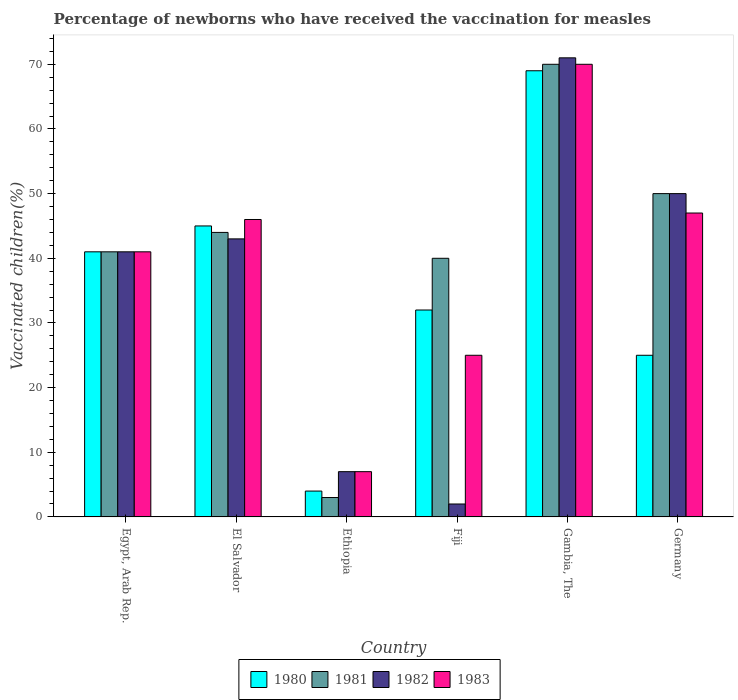How many different coloured bars are there?
Your answer should be very brief. 4. How many groups of bars are there?
Offer a terse response. 6. Are the number of bars per tick equal to the number of legend labels?
Ensure brevity in your answer.  Yes. Are the number of bars on each tick of the X-axis equal?
Provide a short and direct response. Yes. How many bars are there on the 2nd tick from the left?
Give a very brief answer. 4. How many bars are there on the 5th tick from the right?
Provide a succinct answer. 4. What is the label of the 1st group of bars from the left?
Offer a terse response. Egypt, Arab Rep. In which country was the percentage of vaccinated children in 1981 maximum?
Make the answer very short. Gambia, The. In which country was the percentage of vaccinated children in 1980 minimum?
Make the answer very short. Ethiopia. What is the total percentage of vaccinated children in 1982 in the graph?
Provide a short and direct response. 214. What is the difference between the percentage of vaccinated children in 1981 in Egypt, Arab Rep. and that in Germany?
Offer a terse response. -9. What is the average percentage of vaccinated children in 1983 per country?
Your answer should be very brief. 39.33. In how many countries, is the percentage of vaccinated children in 1981 greater than 42 %?
Keep it short and to the point. 3. What is the ratio of the percentage of vaccinated children in 1980 in Egypt, Arab Rep. to that in Fiji?
Provide a short and direct response. 1.28. Is the percentage of vaccinated children in 1981 in Ethiopia less than that in Germany?
Give a very brief answer. Yes. In how many countries, is the percentage of vaccinated children in 1981 greater than the average percentage of vaccinated children in 1981 taken over all countries?
Ensure brevity in your answer.  3. What does the 1st bar from the left in Fiji represents?
Offer a very short reply. 1980. Is it the case that in every country, the sum of the percentage of vaccinated children in 1982 and percentage of vaccinated children in 1981 is greater than the percentage of vaccinated children in 1983?
Provide a short and direct response. Yes. How many bars are there?
Make the answer very short. 24. What is the difference between two consecutive major ticks on the Y-axis?
Keep it short and to the point. 10. Does the graph contain grids?
Your answer should be compact. No. Where does the legend appear in the graph?
Keep it short and to the point. Bottom center. What is the title of the graph?
Provide a succinct answer. Percentage of newborns who have received the vaccination for measles. What is the label or title of the Y-axis?
Offer a terse response. Vaccinated children(%). What is the Vaccinated children(%) of 1982 in Egypt, Arab Rep.?
Make the answer very short. 41. What is the Vaccinated children(%) in 1980 in El Salvador?
Offer a terse response. 45. What is the Vaccinated children(%) of 1983 in El Salvador?
Offer a terse response. 46. What is the Vaccinated children(%) of 1980 in Ethiopia?
Give a very brief answer. 4. What is the Vaccinated children(%) of 1982 in Ethiopia?
Your response must be concise. 7. What is the Vaccinated children(%) of 1983 in Ethiopia?
Offer a very short reply. 7. What is the Vaccinated children(%) of 1981 in Fiji?
Provide a short and direct response. 40. What is the Vaccinated children(%) of 1982 in Fiji?
Ensure brevity in your answer.  2. What is the Vaccinated children(%) in 1982 in Gambia, The?
Keep it short and to the point. 71. What is the Vaccinated children(%) in 1980 in Germany?
Ensure brevity in your answer.  25. Across all countries, what is the maximum Vaccinated children(%) of 1982?
Offer a very short reply. 71. Across all countries, what is the minimum Vaccinated children(%) in 1980?
Keep it short and to the point. 4. Across all countries, what is the minimum Vaccinated children(%) in 1982?
Your answer should be very brief. 2. What is the total Vaccinated children(%) of 1980 in the graph?
Your response must be concise. 216. What is the total Vaccinated children(%) in 1981 in the graph?
Your answer should be compact. 248. What is the total Vaccinated children(%) in 1982 in the graph?
Your answer should be very brief. 214. What is the total Vaccinated children(%) of 1983 in the graph?
Provide a short and direct response. 236. What is the difference between the Vaccinated children(%) of 1981 in Egypt, Arab Rep. and that in El Salvador?
Offer a very short reply. -3. What is the difference between the Vaccinated children(%) of 1982 in Egypt, Arab Rep. and that in El Salvador?
Provide a succinct answer. -2. What is the difference between the Vaccinated children(%) in 1981 in Egypt, Arab Rep. and that in Ethiopia?
Your answer should be very brief. 38. What is the difference between the Vaccinated children(%) in 1983 in Egypt, Arab Rep. and that in Ethiopia?
Keep it short and to the point. 34. What is the difference between the Vaccinated children(%) in 1981 in Egypt, Arab Rep. and that in Fiji?
Offer a very short reply. 1. What is the difference between the Vaccinated children(%) in 1982 in Egypt, Arab Rep. and that in Fiji?
Your answer should be very brief. 39. What is the difference between the Vaccinated children(%) of 1980 in Egypt, Arab Rep. and that in Germany?
Offer a terse response. 16. What is the difference between the Vaccinated children(%) of 1982 in Egypt, Arab Rep. and that in Germany?
Offer a terse response. -9. What is the difference between the Vaccinated children(%) in 1980 in El Salvador and that in Ethiopia?
Ensure brevity in your answer.  41. What is the difference between the Vaccinated children(%) in 1982 in El Salvador and that in Ethiopia?
Your answer should be very brief. 36. What is the difference between the Vaccinated children(%) in 1981 in El Salvador and that in Fiji?
Your answer should be very brief. 4. What is the difference between the Vaccinated children(%) in 1980 in El Salvador and that in Gambia, The?
Offer a very short reply. -24. What is the difference between the Vaccinated children(%) of 1983 in El Salvador and that in Gambia, The?
Provide a short and direct response. -24. What is the difference between the Vaccinated children(%) in 1982 in El Salvador and that in Germany?
Provide a short and direct response. -7. What is the difference between the Vaccinated children(%) in 1983 in El Salvador and that in Germany?
Ensure brevity in your answer.  -1. What is the difference between the Vaccinated children(%) in 1980 in Ethiopia and that in Fiji?
Give a very brief answer. -28. What is the difference between the Vaccinated children(%) in 1981 in Ethiopia and that in Fiji?
Your answer should be very brief. -37. What is the difference between the Vaccinated children(%) of 1980 in Ethiopia and that in Gambia, The?
Offer a terse response. -65. What is the difference between the Vaccinated children(%) of 1981 in Ethiopia and that in Gambia, The?
Your answer should be compact. -67. What is the difference between the Vaccinated children(%) of 1982 in Ethiopia and that in Gambia, The?
Make the answer very short. -64. What is the difference between the Vaccinated children(%) in 1983 in Ethiopia and that in Gambia, The?
Make the answer very short. -63. What is the difference between the Vaccinated children(%) of 1981 in Ethiopia and that in Germany?
Provide a succinct answer. -47. What is the difference between the Vaccinated children(%) of 1982 in Ethiopia and that in Germany?
Your answer should be compact. -43. What is the difference between the Vaccinated children(%) of 1980 in Fiji and that in Gambia, The?
Provide a short and direct response. -37. What is the difference between the Vaccinated children(%) of 1982 in Fiji and that in Gambia, The?
Your response must be concise. -69. What is the difference between the Vaccinated children(%) in 1983 in Fiji and that in Gambia, The?
Ensure brevity in your answer.  -45. What is the difference between the Vaccinated children(%) of 1981 in Fiji and that in Germany?
Your answer should be compact. -10. What is the difference between the Vaccinated children(%) in 1982 in Fiji and that in Germany?
Keep it short and to the point. -48. What is the difference between the Vaccinated children(%) in 1980 in Gambia, The and that in Germany?
Keep it short and to the point. 44. What is the difference between the Vaccinated children(%) of 1981 in Gambia, The and that in Germany?
Give a very brief answer. 20. What is the difference between the Vaccinated children(%) of 1982 in Gambia, The and that in Germany?
Your answer should be very brief. 21. What is the difference between the Vaccinated children(%) of 1983 in Gambia, The and that in Germany?
Your answer should be compact. 23. What is the difference between the Vaccinated children(%) of 1980 in Egypt, Arab Rep. and the Vaccinated children(%) of 1982 in El Salvador?
Keep it short and to the point. -2. What is the difference between the Vaccinated children(%) in 1980 in Egypt, Arab Rep. and the Vaccinated children(%) in 1983 in El Salvador?
Your answer should be very brief. -5. What is the difference between the Vaccinated children(%) in 1981 in Egypt, Arab Rep. and the Vaccinated children(%) in 1982 in El Salvador?
Provide a short and direct response. -2. What is the difference between the Vaccinated children(%) of 1982 in Egypt, Arab Rep. and the Vaccinated children(%) of 1983 in El Salvador?
Provide a succinct answer. -5. What is the difference between the Vaccinated children(%) in 1980 in Egypt, Arab Rep. and the Vaccinated children(%) in 1981 in Ethiopia?
Offer a very short reply. 38. What is the difference between the Vaccinated children(%) of 1982 in Egypt, Arab Rep. and the Vaccinated children(%) of 1983 in Ethiopia?
Your answer should be compact. 34. What is the difference between the Vaccinated children(%) of 1980 in Egypt, Arab Rep. and the Vaccinated children(%) of 1982 in Fiji?
Give a very brief answer. 39. What is the difference between the Vaccinated children(%) of 1980 in Egypt, Arab Rep. and the Vaccinated children(%) of 1983 in Fiji?
Make the answer very short. 16. What is the difference between the Vaccinated children(%) of 1980 in Egypt, Arab Rep. and the Vaccinated children(%) of 1983 in Gambia, The?
Provide a succinct answer. -29. What is the difference between the Vaccinated children(%) in 1981 in Egypt, Arab Rep. and the Vaccinated children(%) in 1982 in Gambia, The?
Your answer should be compact. -30. What is the difference between the Vaccinated children(%) in 1980 in Egypt, Arab Rep. and the Vaccinated children(%) in 1981 in Germany?
Provide a short and direct response. -9. What is the difference between the Vaccinated children(%) in 1980 in Egypt, Arab Rep. and the Vaccinated children(%) in 1982 in Germany?
Make the answer very short. -9. What is the difference between the Vaccinated children(%) of 1980 in Egypt, Arab Rep. and the Vaccinated children(%) of 1983 in Germany?
Provide a short and direct response. -6. What is the difference between the Vaccinated children(%) of 1981 in Egypt, Arab Rep. and the Vaccinated children(%) of 1983 in Germany?
Ensure brevity in your answer.  -6. What is the difference between the Vaccinated children(%) of 1982 in Egypt, Arab Rep. and the Vaccinated children(%) of 1983 in Germany?
Give a very brief answer. -6. What is the difference between the Vaccinated children(%) in 1980 in El Salvador and the Vaccinated children(%) in 1982 in Ethiopia?
Give a very brief answer. 38. What is the difference between the Vaccinated children(%) in 1980 in El Salvador and the Vaccinated children(%) in 1983 in Ethiopia?
Your answer should be very brief. 38. What is the difference between the Vaccinated children(%) in 1982 in El Salvador and the Vaccinated children(%) in 1983 in Ethiopia?
Your answer should be compact. 36. What is the difference between the Vaccinated children(%) in 1980 in El Salvador and the Vaccinated children(%) in 1982 in Fiji?
Keep it short and to the point. 43. What is the difference between the Vaccinated children(%) in 1980 in El Salvador and the Vaccinated children(%) in 1983 in Fiji?
Provide a succinct answer. 20. What is the difference between the Vaccinated children(%) of 1981 in El Salvador and the Vaccinated children(%) of 1982 in Fiji?
Your answer should be compact. 42. What is the difference between the Vaccinated children(%) of 1981 in El Salvador and the Vaccinated children(%) of 1983 in Fiji?
Offer a terse response. 19. What is the difference between the Vaccinated children(%) of 1980 in El Salvador and the Vaccinated children(%) of 1981 in Gambia, The?
Your answer should be compact. -25. What is the difference between the Vaccinated children(%) in 1980 in El Salvador and the Vaccinated children(%) in 1982 in Gambia, The?
Your answer should be compact. -26. What is the difference between the Vaccinated children(%) of 1981 in El Salvador and the Vaccinated children(%) of 1983 in Gambia, The?
Ensure brevity in your answer.  -26. What is the difference between the Vaccinated children(%) in 1982 in El Salvador and the Vaccinated children(%) in 1983 in Gambia, The?
Your response must be concise. -27. What is the difference between the Vaccinated children(%) of 1980 in El Salvador and the Vaccinated children(%) of 1981 in Germany?
Make the answer very short. -5. What is the difference between the Vaccinated children(%) of 1980 in El Salvador and the Vaccinated children(%) of 1982 in Germany?
Give a very brief answer. -5. What is the difference between the Vaccinated children(%) of 1981 in El Salvador and the Vaccinated children(%) of 1983 in Germany?
Provide a succinct answer. -3. What is the difference between the Vaccinated children(%) of 1982 in El Salvador and the Vaccinated children(%) of 1983 in Germany?
Ensure brevity in your answer.  -4. What is the difference between the Vaccinated children(%) in 1980 in Ethiopia and the Vaccinated children(%) in 1981 in Fiji?
Your response must be concise. -36. What is the difference between the Vaccinated children(%) of 1980 in Ethiopia and the Vaccinated children(%) of 1983 in Fiji?
Give a very brief answer. -21. What is the difference between the Vaccinated children(%) in 1981 in Ethiopia and the Vaccinated children(%) in 1983 in Fiji?
Ensure brevity in your answer.  -22. What is the difference between the Vaccinated children(%) of 1980 in Ethiopia and the Vaccinated children(%) of 1981 in Gambia, The?
Keep it short and to the point. -66. What is the difference between the Vaccinated children(%) of 1980 in Ethiopia and the Vaccinated children(%) of 1982 in Gambia, The?
Offer a terse response. -67. What is the difference between the Vaccinated children(%) of 1980 in Ethiopia and the Vaccinated children(%) of 1983 in Gambia, The?
Give a very brief answer. -66. What is the difference between the Vaccinated children(%) in 1981 in Ethiopia and the Vaccinated children(%) in 1982 in Gambia, The?
Provide a succinct answer. -68. What is the difference between the Vaccinated children(%) in 1981 in Ethiopia and the Vaccinated children(%) in 1983 in Gambia, The?
Give a very brief answer. -67. What is the difference between the Vaccinated children(%) in 1982 in Ethiopia and the Vaccinated children(%) in 1983 in Gambia, The?
Keep it short and to the point. -63. What is the difference between the Vaccinated children(%) in 1980 in Ethiopia and the Vaccinated children(%) in 1981 in Germany?
Make the answer very short. -46. What is the difference between the Vaccinated children(%) in 1980 in Ethiopia and the Vaccinated children(%) in 1982 in Germany?
Your response must be concise. -46. What is the difference between the Vaccinated children(%) of 1980 in Ethiopia and the Vaccinated children(%) of 1983 in Germany?
Keep it short and to the point. -43. What is the difference between the Vaccinated children(%) in 1981 in Ethiopia and the Vaccinated children(%) in 1982 in Germany?
Offer a terse response. -47. What is the difference between the Vaccinated children(%) in 1981 in Ethiopia and the Vaccinated children(%) in 1983 in Germany?
Your answer should be very brief. -44. What is the difference between the Vaccinated children(%) of 1980 in Fiji and the Vaccinated children(%) of 1981 in Gambia, The?
Provide a succinct answer. -38. What is the difference between the Vaccinated children(%) in 1980 in Fiji and the Vaccinated children(%) in 1982 in Gambia, The?
Your response must be concise. -39. What is the difference between the Vaccinated children(%) of 1980 in Fiji and the Vaccinated children(%) of 1983 in Gambia, The?
Make the answer very short. -38. What is the difference between the Vaccinated children(%) of 1981 in Fiji and the Vaccinated children(%) of 1982 in Gambia, The?
Make the answer very short. -31. What is the difference between the Vaccinated children(%) in 1981 in Fiji and the Vaccinated children(%) in 1983 in Gambia, The?
Your answer should be very brief. -30. What is the difference between the Vaccinated children(%) in 1982 in Fiji and the Vaccinated children(%) in 1983 in Gambia, The?
Keep it short and to the point. -68. What is the difference between the Vaccinated children(%) in 1980 in Fiji and the Vaccinated children(%) in 1982 in Germany?
Make the answer very short. -18. What is the difference between the Vaccinated children(%) of 1981 in Fiji and the Vaccinated children(%) of 1982 in Germany?
Your answer should be compact. -10. What is the difference between the Vaccinated children(%) of 1981 in Fiji and the Vaccinated children(%) of 1983 in Germany?
Your answer should be very brief. -7. What is the difference between the Vaccinated children(%) of 1982 in Fiji and the Vaccinated children(%) of 1983 in Germany?
Your response must be concise. -45. What is the difference between the Vaccinated children(%) in 1980 in Gambia, The and the Vaccinated children(%) in 1982 in Germany?
Your answer should be very brief. 19. What is the difference between the Vaccinated children(%) in 1980 in Gambia, The and the Vaccinated children(%) in 1983 in Germany?
Offer a very short reply. 22. What is the average Vaccinated children(%) in 1980 per country?
Keep it short and to the point. 36. What is the average Vaccinated children(%) in 1981 per country?
Give a very brief answer. 41.33. What is the average Vaccinated children(%) in 1982 per country?
Your answer should be compact. 35.67. What is the average Vaccinated children(%) in 1983 per country?
Provide a succinct answer. 39.33. What is the difference between the Vaccinated children(%) of 1980 and Vaccinated children(%) of 1983 in Egypt, Arab Rep.?
Offer a terse response. 0. What is the difference between the Vaccinated children(%) of 1981 and Vaccinated children(%) of 1982 in Egypt, Arab Rep.?
Give a very brief answer. 0. What is the difference between the Vaccinated children(%) in 1982 and Vaccinated children(%) in 1983 in Egypt, Arab Rep.?
Provide a short and direct response. 0. What is the difference between the Vaccinated children(%) in 1980 and Vaccinated children(%) in 1982 in El Salvador?
Provide a short and direct response. 2. What is the difference between the Vaccinated children(%) in 1981 and Vaccinated children(%) in 1982 in El Salvador?
Ensure brevity in your answer.  1. What is the difference between the Vaccinated children(%) of 1982 and Vaccinated children(%) of 1983 in El Salvador?
Your response must be concise. -3. What is the difference between the Vaccinated children(%) of 1981 and Vaccinated children(%) of 1982 in Ethiopia?
Offer a very short reply. -4. What is the difference between the Vaccinated children(%) in 1981 and Vaccinated children(%) in 1983 in Ethiopia?
Your response must be concise. -4. What is the difference between the Vaccinated children(%) of 1982 and Vaccinated children(%) of 1983 in Ethiopia?
Keep it short and to the point. 0. What is the difference between the Vaccinated children(%) in 1980 and Vaccinated children(%) in 1981 in Fiji?
Offer a terse response. -8. What is the difference between the Vaccinated children(%) in 1980 and Vaccinated children(%) in 1983 in Fiji?
Provide a succinct answer. 7. What is the difference between the Vaccinated children(%) in 1981 and Vaccinated children(%) in 1983 in Fiji?
Offer a terse response. 15. What is the difference between the Vaccinated children(%) in 1980 and Vaccinated children(%) in 1981 in Gambia, The?
Ensure brevity in your answer.  -1. What is the difference between the Vaccinated children(%) of 1980 and Vaccinated children(%) of 1982 in Gambia, The?
Give a very brief answer. -2. What is the difference between the Vaccinated children(%) in 1980 and Vaccinated children(%) in 1983 in Gambia, The?
Your answer should be very brief. -1. What is the difference between the Vaccinated children(%) in 1981 and Vaccinated children(%) in 1982 in Gambia, The?
Your answer should be compact. -1. What is the difference between the Vaccinated children(%) of 1981 and Vaccinated children(%) of 1983 in Gambia, The?
Offer a terse response. 0. What is the difference between the Vaccinated children(%) in 1982 and Vaccinated children(%) in 1983 in Gambia, The?
Offer a terse response. 1. What is the difference between the Vaccinated children(%) of 1981 and Vaccinated children(%) of 1982 in Germany?
Keep it short and to the point. 0. What is the ratio of the Vaccinated children(%) in 1980 in Egypt, Arab Rep. to that in El Salvador?
Ensure brevity in your answer.  0.91. What is the ratio of the Vaccinated children(%) of 1981 in Egypt, Arab Rep. to that in El Salvador?
Make the answer very short. 0.93. What is the ratio of the Vaccinated children(%) of 1982 in Egypt, Arab Rep. to that in El Salvador?
Your answer should be compact. 0.95. What is the ratio of the Vaccinated children(%) of 1983 in Egypt, Arab Rep. to that in El Salvador?
Your response must be concise. 0.89. What is the ratio of the Vaccinated children(%) in 1980 in Egypt, Arab Rep. to that in Ethiopia?
Offer a very short reply. 10.25. What is the ratio of the Vaccinated children(%) in 1981 in Egypt, Arab Rep. to that in Ethiopia?
Your answer should be compact. 13.67. What is the ratio of the Vaccinated children(%) of 1982 in Egypt, Arab Rep. to that in Ethiopia?
Provide a succinct answer. 5.86. What is the ratio of the Vaccinated children(%) in 1983 in Egypt, Arab Rep. to that in Ethiopia?
Make the answer very short. 5.86. What is the ratio of the Vaccinated children(%) in 1980 in Egypt, Arab Rep. to that in Fiji?
Keep it short and to the point. 1.28. What is the ratio of the Vaccinated children(%) of 1983 in Egypt, Arab Rep. to that in Fiji?
Provide a succinct answer. 1.64. What is the ratio of the Vaccinated children(%) of 1980 in Egypt, Arab Rep. to that in Gambia, The?
Give a very brief answer. 0.59. What is the ratio of the Vaccinated children(%) of 1981 in Egypt, Arab Rep. to that in Gambia, The?
Offer a terse response. 0.59. What is the ratio of the Vaccinated children(%) of 1982 in Egypt, Arab Rep. to that in Gambia, The?
Your answer should be compact. 0.58. What is the ratio of the Vaccinated children(%) in 1983 in Egypt, Arab Rep. to that in Gambia, The?
Ensure brevity in your answer.  0.59. What is the ratio of the Vaccinated children(%) in 1980 in Egypt, Arab Rep. to that in Germany?
Offer a terse response. 1.64. What is the ratio of the Vaccinated children(%) in 1981 in Egypt, Arab Rep. to that in Germany?
Your answer should be compact. 0.82. What is the ratio of the Vaccinated children(%) of 1982 in Egypt, Arab Rep. to that in Germany?
Give a very brief answer. 0.82. What is the ratio of the Vaccinated children(%) of 1983 in Egypt, Arab Rep. to that in Germany?
Make the answer very short. 0.87. What is the ratio of the Vaccinated children(%) in 1980 in El Salvador to that in Ethiopia?
Your answer should be very brief. 11.25. What is the ratio of the Vaccinated children(%) of 1981 in El Salvador to that in Ethiopia?
Your answer should be compact. 14.67. What is the ratio of the Vaccinated children(%) in 1982 in El Salvador to that in Ethiopia?
Your answer should be compact. 6.14. What is the ratio of the Vaccinated children(%) in 1983 in El Salvador to that in Ethiopia?
Your answer should be very brief. 6.57. What is the ratio of the Vaccinated children(%) of 1980 in El Salvador to that in Fiji?
Make the answer very short. 1.41. What is the ratio of the Vaccinated children(%) in 1981 in El Salvador to that in Fiji?
Ensure brevity in your answer.  1.1. What is the ratio of the Vaccinated children(%) of 1983 in El Salvador to that in Fiji?
Your response must be concise. 1.84. What is the ratio of the Vaccinated children(%) in 1980 in El Salvador to that in Gambia, The?
Your answer should be very brief. 0.65. What is the ratio of the Vaccinated children(%) in 1981 in El Salvador to that in Gambia, The?
Give a very brief answer. 0.63. What is the ratio of the Vaccinated children(%) of 1982 in El Salvador to that in Gambia, The?
Your response must be concise. 0.61. What is the ratio of the Vaccinated children(%) in 1983 in El Salvador to that in Gambia, The?
Provide a succinct answer. 0.66. What is the ratio of the Vaccinated children(%) in 1980 in El Salvador to that in Germany?
Your answer should be compact. 1.8. What is the ratio of the Vaccinated children(%) of 1982 in El Salvador to that in Germany?
Make the answer very short. 0.86. What is the ratio of the Vaccinated children(%) of 1983 in El Salvador to that in Germany?
Your answer should be compact. 0.98. What is the ratio of the Vaccinated children(%) in 1980 in Ethiopia to that in Fiji?
Your answer should be very brief. 0.12. What is the ratio of the Vaccinated children(%) of 1981 in Ethiopia to that in Fiji?
Your response must be concise. 0.07. What is the ratio of the Vaccinated children(%) of 1982 in Ethiopia to that in Fiji?
Your answer should be compact. 3.5. What is the ratio of the Vaccinated children(%) of 1983 in Ethiopia to that in Fiji?
Give a very brief answer. 0.28. What is the ratio of the Vaccinated children(%) of 1980 in Ethiopia to that in Gambia, The?
Your answer should be very brief. 0.06. What is the ratio of the Vaccinated children(%) in 1981 in Ethiopia to that in Gambia, The?
Your answer should be very brief. 0.04. What is the ratio of the Vaccinated children(%) in 1982 in Ethiopia to that in Gambia, The?
Keep it short and to the point. 0.1. What is the ratio of the Vaccinated children(%) of 1983 in Ethiopia to that in Gambia, The?
Your response must be concise. 0.1. What is the ratio of the Vaccinated children(%) in 1980 in Ethiopia to that in Germany?
Your answer should be very brief. 0.16. What is the ratio of the Vaccinated children(%) of 1981 in Ethiopia to that in Germany?
Offer a very short reply. 0.06. What is the ratio of the Vaccinated children(%) in 1982 in Ethiopia to that in Germany?
Your answer should be compact. 0.14. What is the ratio of the Vaccinated children(%) of 1983 in Ethiopia to that in Germany?
Provide a succinct answer. 0.15. What is the ratio of the Vaccinated children(%) of 1980 in Fiji to that in Gambia, The?
Your answer should be very brief. 0.46. What is the ratio of the Vaccinated children(%) in 1982 in Fiji to that in Gambia, The?
Ensure brevity in your answer.  0.03. What is the ratio of the Vaccinated children(%) of 1983 in Fiji to that in Gambia, The?
Offer a very short reply. 0.36. What is the ratio of the Vaccinated children(%) of 1980 in Fiji to that in Germany?
Your response must be concise. 1.28. What is the ratio of the Vaccinated children(%) of 1981 in Fiji to that in Germany?
Offer a terse response. 0.8. What is the ratio of the Vaccinated children(%) in 1982 in Fiji to that in Germany?
Give a very brief answer. 0.04. What is the ratio of the Vaccinated children(%) in 1983 in Fiji to that in Germany?
Your answer should be compact. 0.53. What is the ratio of the Vaccinated children(%) in 1980 in Gambia, The to that in Germany?
Offer a very short reply. 2.76. What is the ratio of the Vaccinated children(%) of 1981 in Gambia, The to that in Germany?
Provide a succinct answer. 1.4. What is the ratio of the Vaccinated children(%) of 1982 in Gambia, The to that in Germany?
Provide a short and direct response. 1.42. What is the ratio of the Vaccinated children(%) of 1983 in Gambia, The to that in Germany?
Make the answer very short. 1.49. What is the difference between the highest and the second highest Vaccinated children(%) of 1980?
Keep it short and to the point. 24. What is the difference between the highest and the second highest Vaccinated children(%) of 1981?
Make the answer very short. 20. What is the difference between the highest and the lowest Vaccinated children(%) in 1983?
Ensure brevity in your answer.  63. 